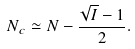<formula> <loc_0><loc_0><loc_500><loc_500>N _ { c } \simeq N - \frac { \sqrt { I } - 1 } { 2 } .</formula> 